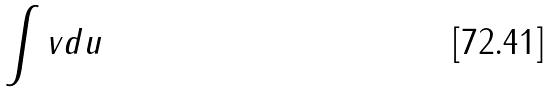<formula> <loc_0><loc_0><loc_500><loc_500>\int v d u</formula> 